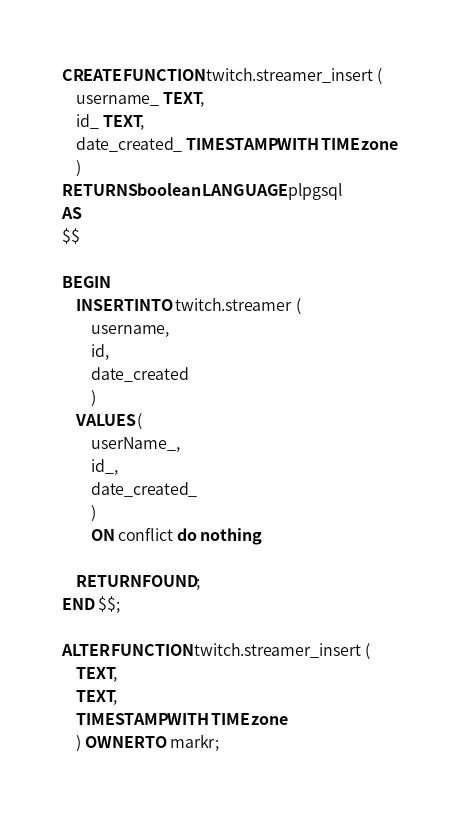<code> <loc_0><loc_0><loc_500><loc_500><_SQL_>CREATE FUNCTION twitch.streamer_insert (
    username_ TEXT,
    id_ TEXT,
    date_created_ TIMESTAMP WITH TIME zone
    )
RETURNS boolean LANGUAGE plpgsql
AS
$$

BEGIN
    INSERT INTO twitch.streamer (
        username,
        id,
        date_created
        )
    VALUES (
        userName_,
        id_,
        date_created_
        )
        ON conflict do nothing;

    RETURN FOUND;
END $$;

ALTER FUNCTION twitch.streamer_insert (
    TEXT,
    TEXT,
    TIMESTAMP WITH TIME zone
    ) OWNER TO markr;
</code> 